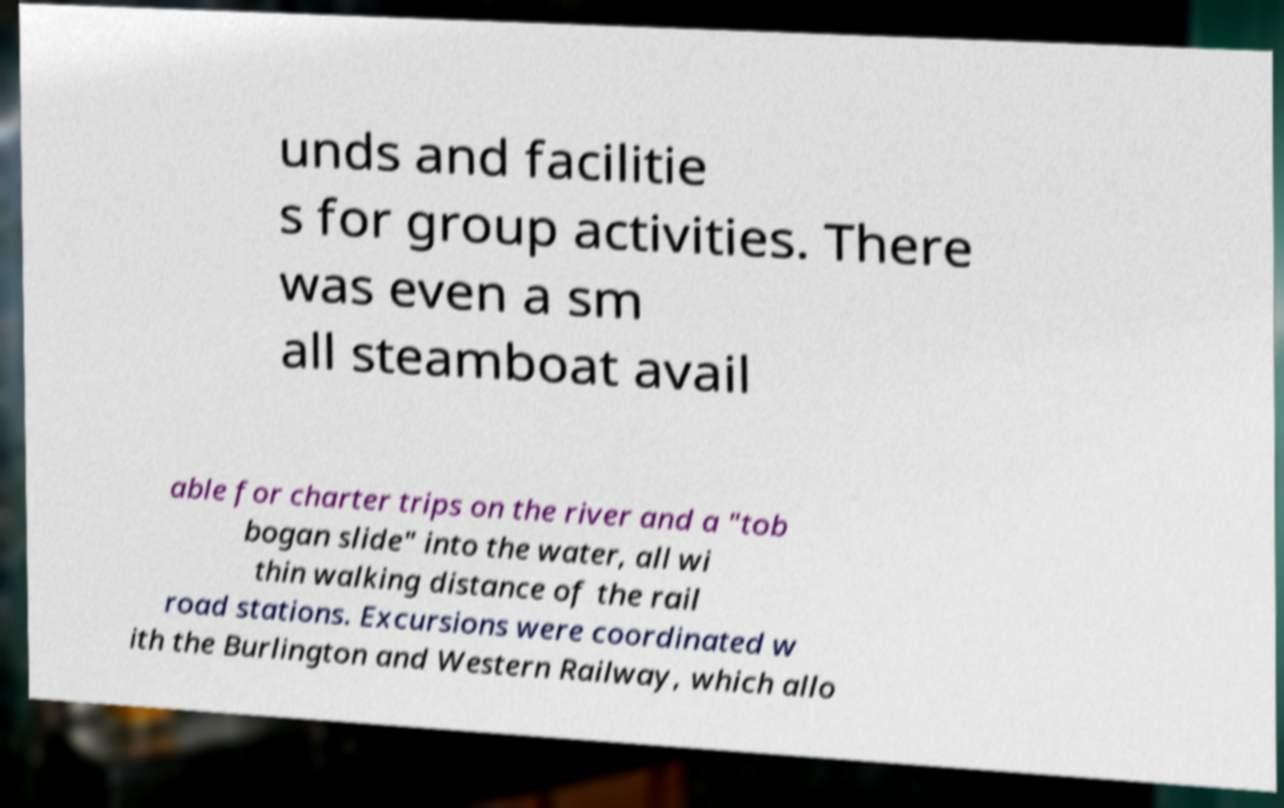Can you accurately transcribe the text from the provided image for me? unds and facilitie s for group activities. There was even a sm all steamboat avail able for charter trips on the river and a "tob bogan slide" into the water, all wi thin walking distance of the rail road stations. Excursions were coordinated w ith the Burlington and Western Railway, which allo 